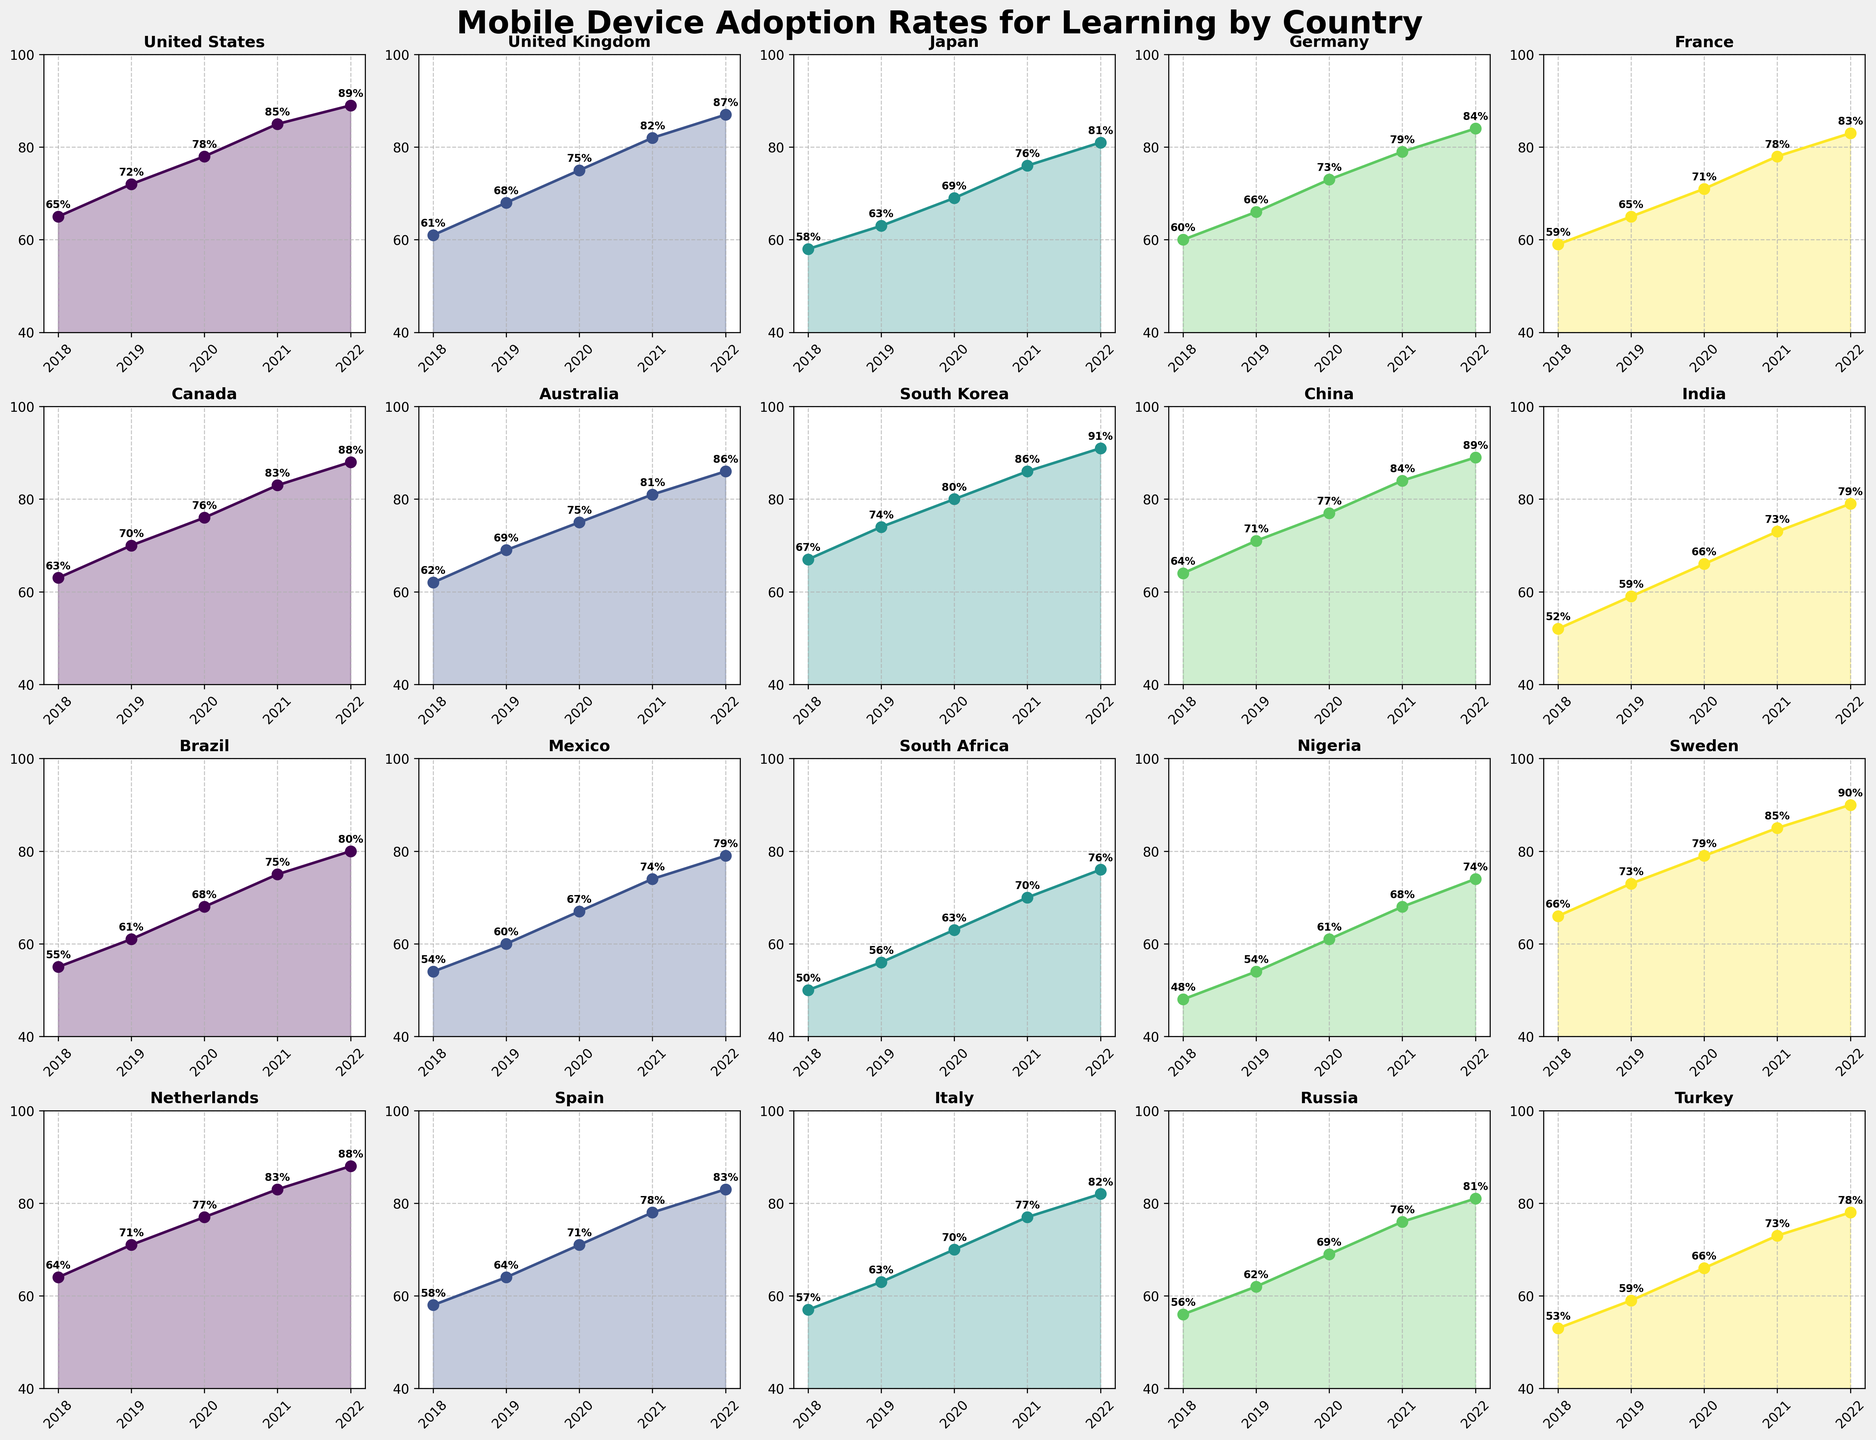Which country had the highest adoption rate in 2022? By looking at the plots, identify the country with the highest y-axis value in 2022. Specifically, South Korea has the highest point at 91%.
Answer: South Korea Which two countries had similar adoption rates in 2019? Compare the plots, focus on the points for 2019, and identify the countries with closely matching values. United States and China both have rates at 71%.
Answer: United States and China What's the average adoption rate for Italy over the years? Sum up Italy's adoption values from 2018 to 2022 and divide by the number of years. (57 + 63 + 70 + 77 + 82) / 5 = 69.8
Answer: 69.8 In which year did France see the largest increase in adoption rate? Look at France's plot and calculate the year-by-year differences; the biggest difference is between 2021 and 2022 (83 - 78 = 5).
Answer: 2022 Compare the adoption rates of Germany and Canada in 2021. Which was higher? In 2021, identify the points for Germany and Canada. Canada's point is higher at 83% compared to Germany's 79%.
Answer: Canada Which country showed a constant growth in adoption rate without any decreases? Examine the trajectories of the plots to find a country with steady upward movement. The United Kingdom's plot shows constant growth from 61% to 87%.
Answer: United Kingdom What color represents the data points for Australia? Determine the color used in Australia's subplot based on the visual diagram. It is represented in a light greenish hue as per the gradients used in the plots.
Answer: Light Green Which country had the lowest adoption rate in 2018 and what was it? Identify the country with the smallest y-axis value at the 2018 mark. Nigeria is the lowest at 48%.
Answer: Nigeria, 48% How much did Spain's adoption rate increase from 2019 to 2020? For Spain, subtract the 2019 adoption rate from the 2020 rate (71 - 64) = 7.
Answer: 7 Identify the year where Mexico’s adoption rate reached 74%. Check Mexico’s plot to see where the data point reaches 74%, which is in year 2021.
Answer: 2021 